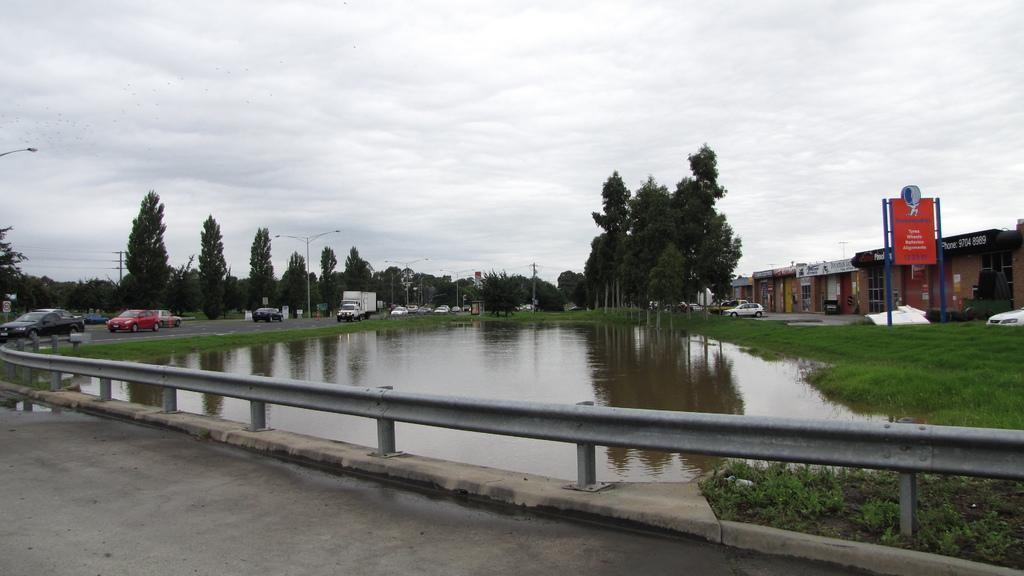Please provide a concise description of this image. In the foreground I can see a bridge, fence, grass, water, fleets of vehicles on the road and trees. In the background I can see boards, buildings, light poles, wires and the sky. This image is taken may be during a day. 